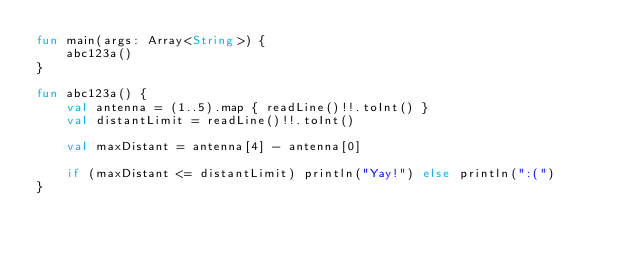Convert code to text. <code><loc_0><loc_0><loc_500><loc_500><_Kotlin_>fun main(args: Array<String>) {
    abc123a()
}

fun abc123a() {
    val antenna = (1..5).map { readLine()!!.toInt() }
    val distantLimit = readLine()!!.toInt()

    val maxDistant = antenna[4] - antenna[0]

    if (maxDistant <= distantLimit) println("Yay!") else println(":(")
}
</code> 